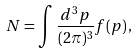<formula> <loc_0><loc_0><loc_500><loc_500>N = \int \frac { d ^ { 3 } p } { ( 2 \pi ) ^ { 3 } } f ( p ) \, ,</formula> 